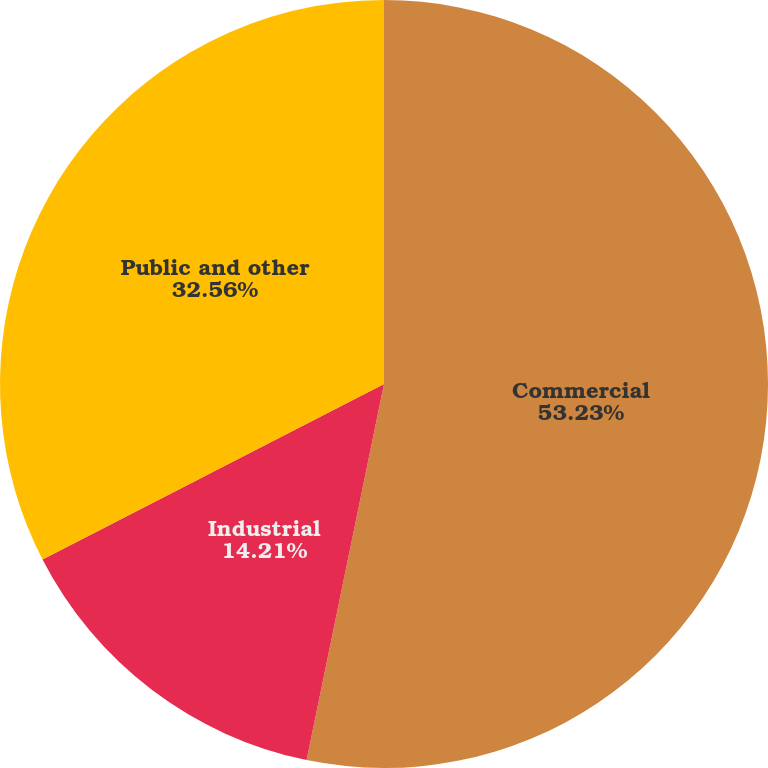Convert chart to OTSL. <chart><loc_0><loc_0><loc_500><loc_500><pie_chart><fcel>Commercial<fcel>Industrial<fcel>Public and other<nl><fcel>53.23%<fcel>14.21%<fcel>32.56%<nl></chart> 